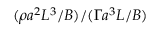Convert formula to latex. <formula><loc_0><loc_0><loc_500><loc_500>( \rho a ^ { 2 } L ^ { 3 } / B ) / ( \Gamma a ^ { 3 } L / B )</formula> 